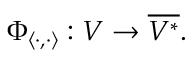Convert formula to latex. <formula><loc_0><loc_0><loc_500><loc_500>\Phi _ { \langle \cdot , \cdot \rangle } \colon V \to { \overline { { V ^ { * } } } } .</formula> 